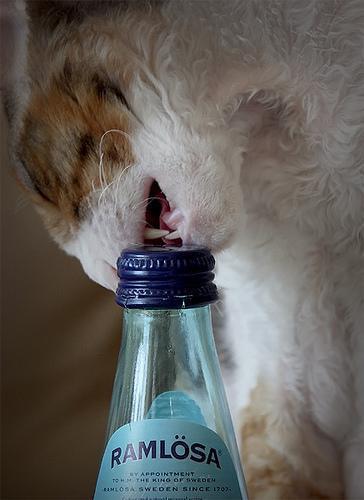How many people are holding a remote controller?
Give a very brief answer. 0. 